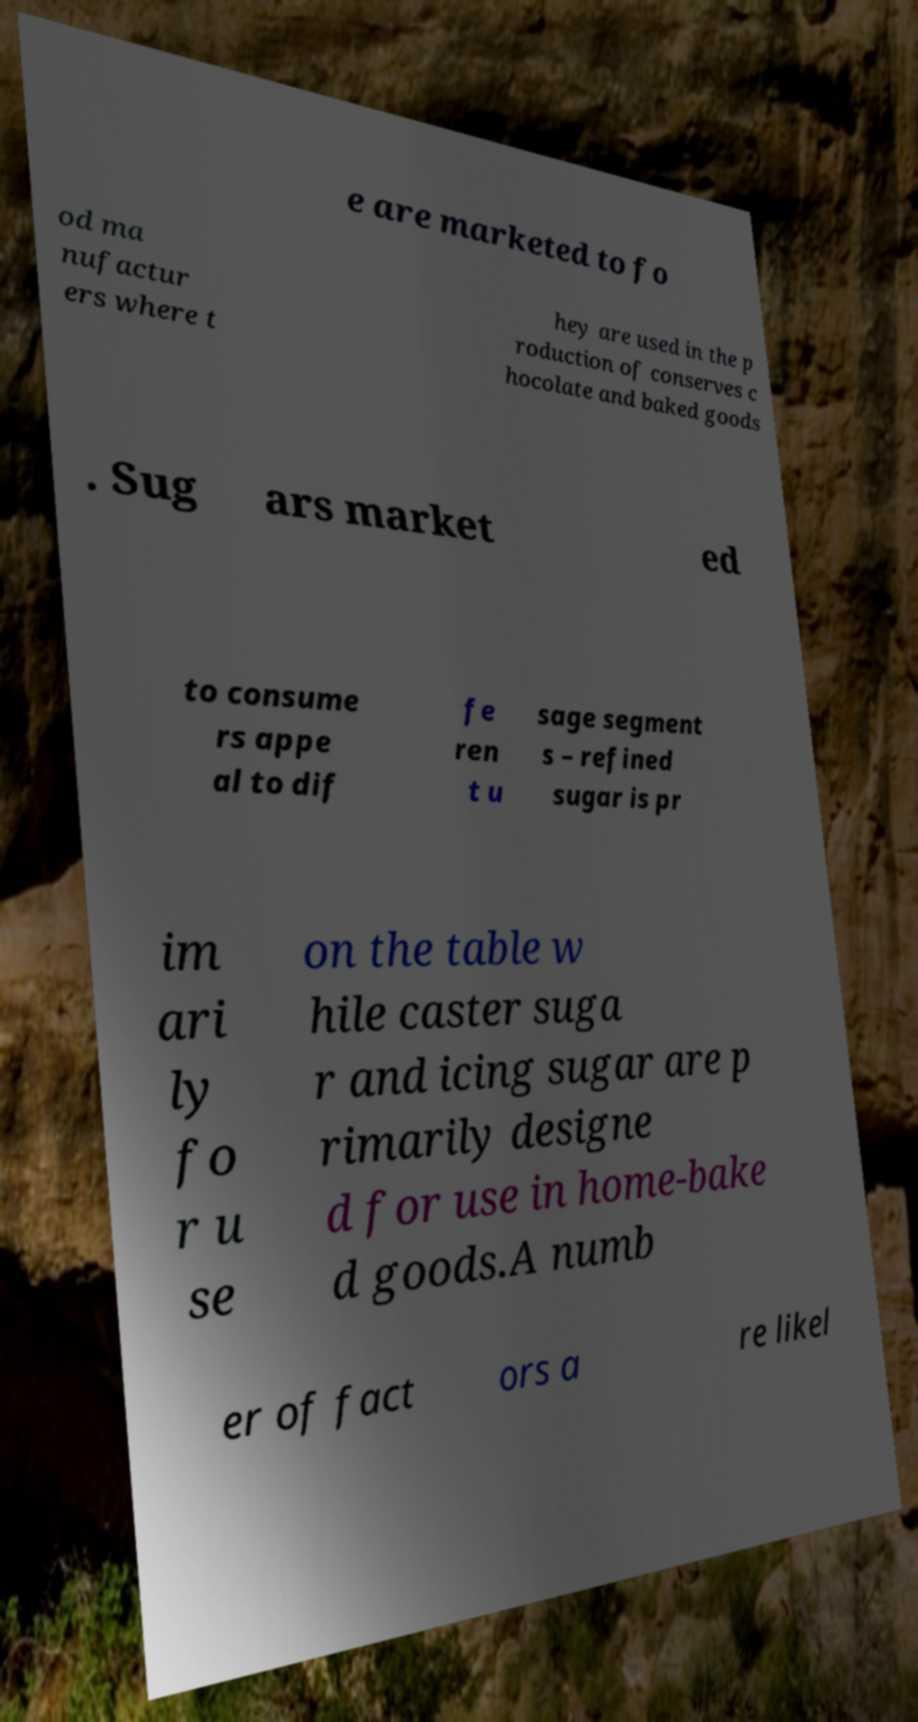I need the written content from this picture converted into text. Can you do that? e are marketed to fo od ma nufactur ers where t hey are used in the p roduction of conserves c hocolate and baked goods . Sug ars market ed to consume rs appe al to dif fe ren t u sage segment s – refined sugar is pr im ari ly fo r u se on the table w hile caster suga r and icing sugar are p rimarily designe d for use in home-bake d goods.A numb er of fact ors a re likel 